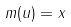Convert formula to latex. <formula><loc_0><loc_0><loc_500><loc_500>m ( u ) = x</formula> 